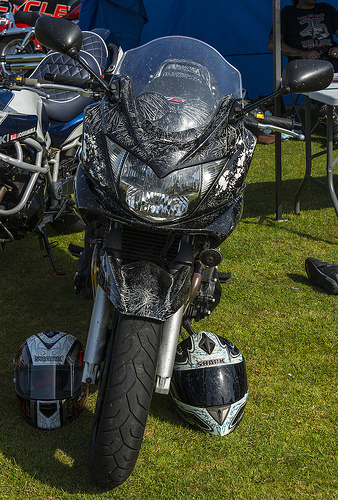<image>
Is the helmet on the bike? No. The helmet is not positioned on the bike. They may be near each other, but the helmet is not supported by or resting on top of the bike. 